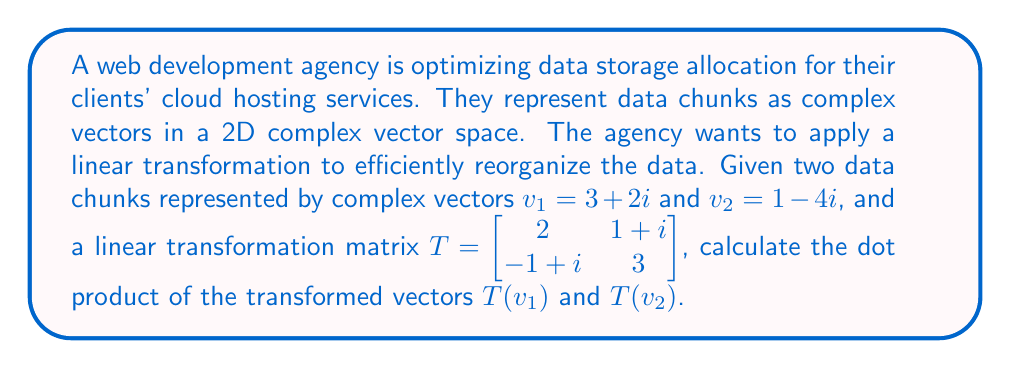Show me your answer to this math problem. To solve this problem, we'll follow these steps:

1) First, we need to apply the linear transformation T to both vectors $v_1$ and $v_2$.

   For $v_1 = 3+2i$:
   $$T(v_1) = \begin{bmatrix} 2 & 1+i \\ -1+i & 3 \end{bmatrix} \begin{bmatrix} 3 \\ 2i \end{bmatrix}$$
   $$= \begin{bmatrix} 2(3) + (1+i)(2i) \\ (-1+i)(3) + 3(2i) \end{bmatrix}$$
   $$= \begin{bmatrix} 6 + 2i - 2 \\ -3 + 3i + 6i \end{bmatrix}$$
   $$= \begin{bmatrix} 4 + 2i \\ -3 + 9i \end{bmatrix}$$

   For $v_2 = 1-4i$:
   $$T(v_2) = \begin{bmatrix} 2 & 1+i \\ -1+i & 3 \end{bmatrix} \begin{bmatrix} 1 \\ -4i \end{bmatrix}$$
   $$= \begin{bmatrix} 2(1) + (1+i)(-4i) \\ (-1+i)(1) + 3(-4i) \end{bmatrix}$$
   $$= \begin{bmatrix} 2 - 4i - 4 \\ -1 + i - 12i \end{bmatrix}$$
   $$= \begin{bmatrix} -2 - 4i \\ -1 - 11i \end{bmatrix}$$

2) Now that we have $T(v_1)$ and $T(v_2)$, we need to calculate their dot product.
   The dot product of two complex vectors $a+bi$ and $c+di$ is defined as $(ac+bd) + (ad-bc)i$.

   $T(v_1) = (4+2i) + (-3+9i)j = 4+2i-3j+9ij$
   $T(v_2) = (-2-4i) + (-1-11i)j = -2-4i-j-11ij$

3) Multiplying these:
   $(4+2i-3j+9ij)(-2-4i-j-11ij)$
   $= -8-16i-4j-44ij-6i+12-3ij+33j-18j-36ij+54ij-99$
   $= 4-22i+25j-29ij$

4) The real part is the dot product:
   $4 + 25 = 29$

Therefore, the dot product of $T(v_1)$ and $T(v_2)$ is 29.
Answer: 29 